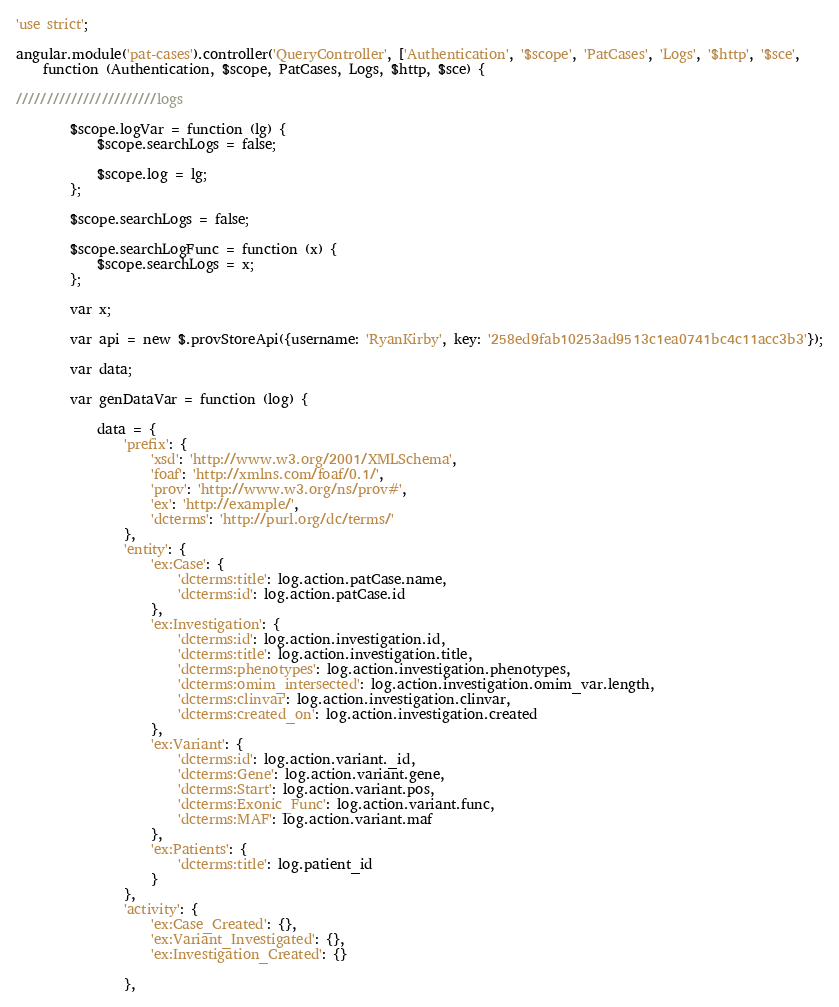Convert code to text. <code><loc_0><loc_0><loc_500><loc_500><_JavaScript_>'use strict';

angular.module('pat-cases').controller('QueryController', ['Authentication', '$scope', 'PatCases', 'Logs', '$http', '$sce',
    function (Authentication, $scope, PatCases, Logs, $http, $sce) {

///////////////////////logs

        $scope.logVar = function (lg) {
            $scope.searchLogs = false;

            $scope.log = lg;
        };

        $scope.searchLogs = false;

        $scope.searchLogFunc = function (x) {
            $scope.searchLogs = x;
        };

        var x;

        var api = new $.provStoreApi({username: 'RyanKirby', key: '258ed9fab10253ad9513c1ea0741bc4c11acc3b3'});

        var data;

        var genDataVar = function (log) {

            data = {
                'prefix': {
                    'xsd': 'http://www.w3.org/2001/XMLSchema',
                    'foaf': 'http://xmlns.com/foaf/0.1/',
                    'prov': 'http://www.w3.org/ns/prov#',
                    'ex': 'http://example/',
                    'dcterms': 'http://purl.org/dc/terms/'
                },
                'entity': {
                    'ex:Case': {
                        'dcterms:title': log.action.patCase.name,
                        'dcterms:id': log.action.patCase.id
                    },
                    'ex:Investigation': {
                        'dcterms:id': log.action.investigation.id,
                        'dcterms:title': log.action.investigation.title,
                        'dcterms:phenotypes': log.action.investigation.phenotypes,
                        'dcterms:omim_intersected': log.action.investigation.omim_var.length,
                        'dcterms:clinvar': log.action.investigation.clinvar,
                        'dcterms:created_on': log.action.investigation.created
                    },
                    'ex:Variant': {
                        'dcterms:id': log.action.variant._id,
                        'dcterms:Gene': log.action.variant.gene,
                        'dcterms:Start': log.action.variant.pos,
                        'dcterms:Exonic_Func': log.action.variant.func,
                        'dcterms:MAF': log.action.variant.maf
                    },
                    'ex:Patients': {
                        'dcterms:title': log.patient_id
                    }
                },
                'activity': {
                    'ex:Case_Created': {},
                    'ex:Variant_Investigated': {},
                    'ex:Investigation_Created': {}

                },</code> 